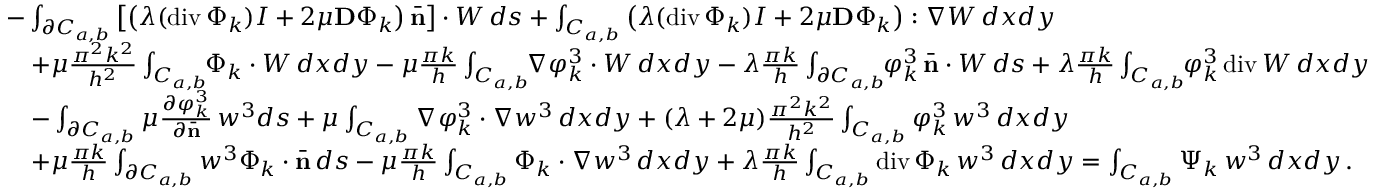Convert formula to latex. <formula><loc_0><loc_0><loc_500><loc_500>\begin{array} { r l } & { - \int _ { \partial C _ { a , b } } \left [ \left ( \lambda ( d i v \, \Phi _ { k } ) I + 2 \mu { D } \Phi _ { k } \right ) \bar { n } \right ] \cdot W \, d s + \int _ { C _ { a , b } } \left ( \lambda ( d i v \, \Phi _ { k } ) I + 2 \mu { D } \Phi _ { k } \right ) \colon \nabla W \, d x d y } \\ & { \quad + \mu \frac { \pi ^ { 2 } k ^ { 2 } } { h ^ { 2 } } \int _ { C _ { a , b } } \, \Phi _ { k } \cdot W \, d x d y - \mu \frac { \pi k } { h } \int _ { C _ { a , b } } \, \nabla \varphi _ { k } ^ { 3 } \cdot W \, d x d y - \lambda \frac { \pi k } { h } \int _ { \partial C _ { a , b } } \, \varphi _ { k } ^ { 3 } \, \bar { n } \cdot W \, d s + \lambda \frac { \pi k } { h } \int _ { C _ { a , b } } \, \varphi _ { k } ^ { 3 } \, d i v \, W \, d x d y } \\ & { \quad - \int _ { \partial C _ { a , b } } \mu \frac { \partial \varphi _ { k } ^ { 3 } } { \partial \bar { n } } \, w ^ { 3 } d s + \mu \int _ { C _ { a , b } } \nabla \varphi _ { k } ^ { 3 } \cdot \nabla w ^ { 3 } \, d x d y + ( \lambda + 2 \mu ) \frac { \pi ^ { 2 } k ^ { 2 } } { h ^ { 2 } } \int _ { C _ { a , b } } \varphi _ { k } ^ { 3 } \, w ^ { 3 } \, d x d y } \\ & { \quad + \mu \frac { \pi k } { h } \int _ { \partial C _ { a , b } } w ^ { 3 } \Phi _ { k } \cdot \bar { n } \, d s - \mu \frac { \pi k } { h } \int _ { C _ { a , b } } \Phi _ { k } \cdot \nabla w ^ { 3 } \, d x d y + \lambda \frac { \pi k } { h } \int _ { C _ { a , b } } d i v \, \Phi _ { k } \, w ^ { 3 } \, d x d y = \int _ { C _ { a , b } } \Psi _ { k } \, w ^ { 3 } \, d x d y \, . } \end{array}</formula> 